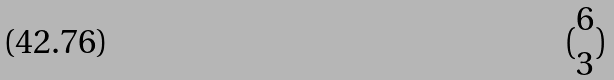Convert formula to latex. <formula><loc_0><loc_0><loc_500><loc_500>( \begin{matrix} 6 \\ 3 \end{matrix} )</formula> 